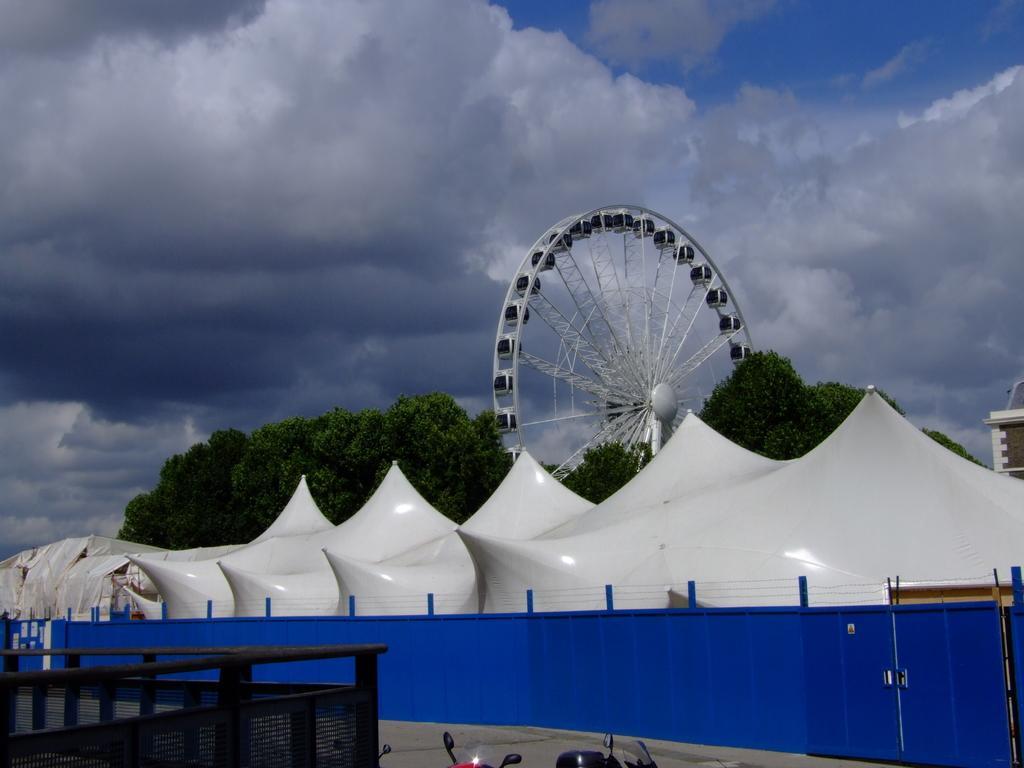How would you summarize this image in a sentence or two? This picture is clicked outside. In the foreground we can see the bikes parked on the ground. On the left we can see the metal rods and the mesh. In the center we can see the fence and some white color objects. In the background we can see the sky which is full of clouds and we can see the trees and a Ferris wheel. In the right corner we can see the building. 